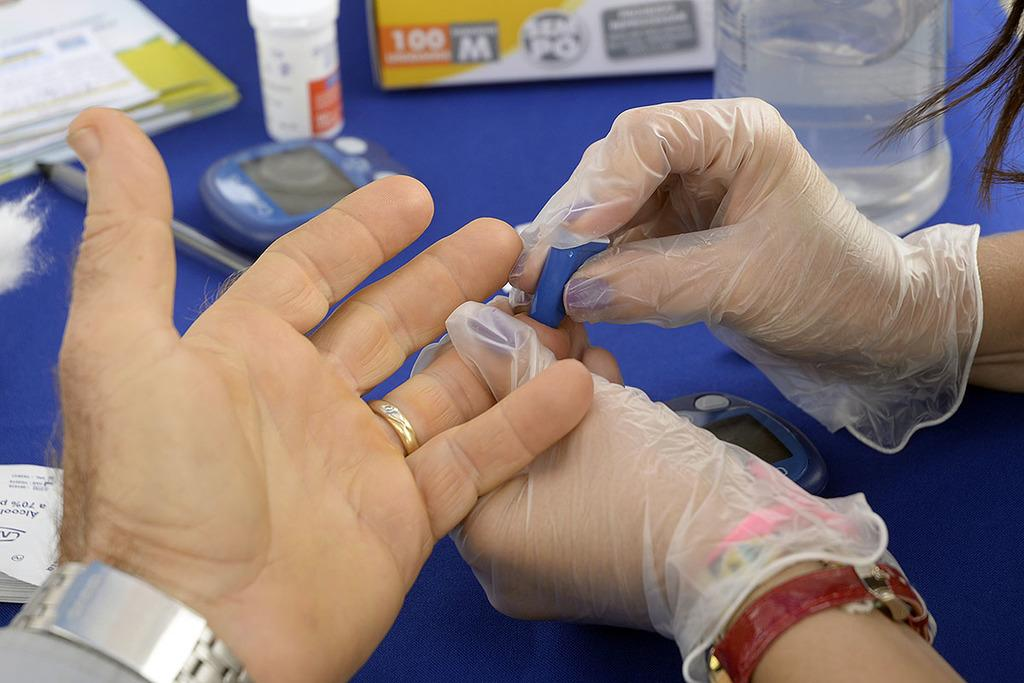What part of a person can be seen in the image? There is a person's hand in the image. What is on the table in the image? There is a bottle, a book, and a pen on the table in the image. Are there any other objects on the table in the image? Yes, there are some other objects on the table in the image. Can you see a bear playing on a swing in the image? No, there is no bear or swing present in the image. 